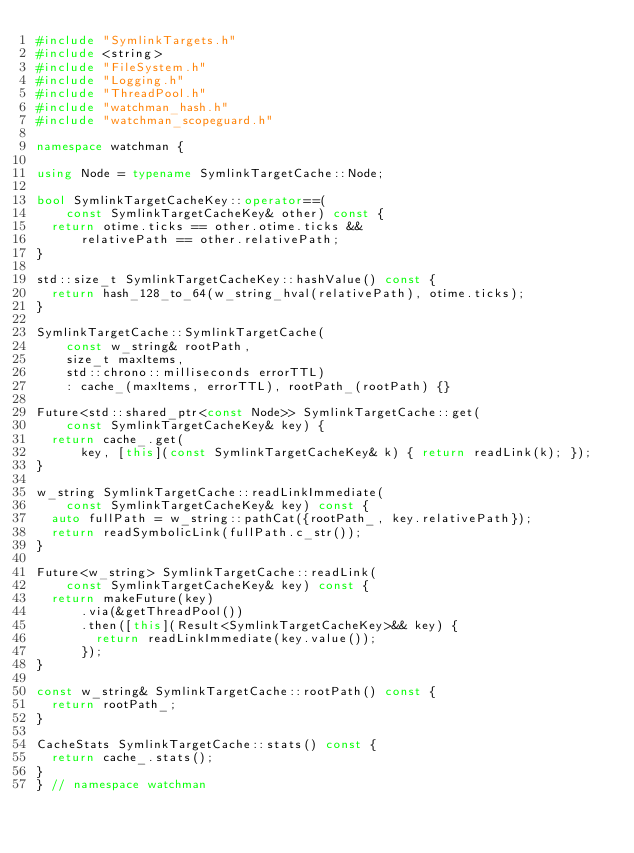Convert code to text. <code><loc_0><loc_0><loc_500><loc_500><_C++_>#include "SymlinkTargets.h"
#include <string>
#include "FileSystem.h"
#include "Logging.h"
#include "ThreadPool.h"
#include "watchman_hash.h"
#include "watchman_scopeguard.h"

namespace watchman {

using Node = typename SymlinkTargetCache::Node;

bool SymlinkTargetCacheKey::operator==(
    const SymlinkTargetCacheKey& other) const {
  return otime.ticks == other.otime.ticks &&
      relativePath == other.relativePath;
}

std::size_t SymlinkTargetCacheKey::hashValue() const {
  return hash_128_to_64(w_string_hval(relativePath), otime.ticks);
}

SymlinkTargetCache::SymlinkTargetCache(
    const w_string& rootPath,
    size_t maxItems,
    std::chrono::milliseconds errorTTL)
    : cache_(maxItems, errorTTL), rootPath_(rootPath) {}

Future<std::shared_ptr<const Node>> SymlinkTargetCache::get(
    const SymlinkTargetCacheKey& key) {
  return cache_.get(
      key, [this](const SymlinkTargetCacheKey& k) { return readLink(k); });
}

w_string SymlinkTargetCache::readLinkImmediate(
    const SymlinkTargetCacheKey& key) const {
  auto fullPath = w_string::pathCat({rootPath_, key.relativePath});
  return readSymbolicLink(fullPath.c_str());
}

Future<w_string> SymlinkTargetCache::readLink(
    const SymlinkTargetCacheKey& key) const {
  return makeFuture(key)
      .via(&getThreadPool())
      .then([this](Result<SymlinkTargetCacheKey>&& key) {
        return readLinkImmediate(key.value());
      });
}

const w_string& SymlinkTargetCache::rootPath() const {
  return rootPath_;
}

CacheStats SymlinkTargetCache::stats() const {
  return cache_.stats();
}
} // namespace watchman
</code> 